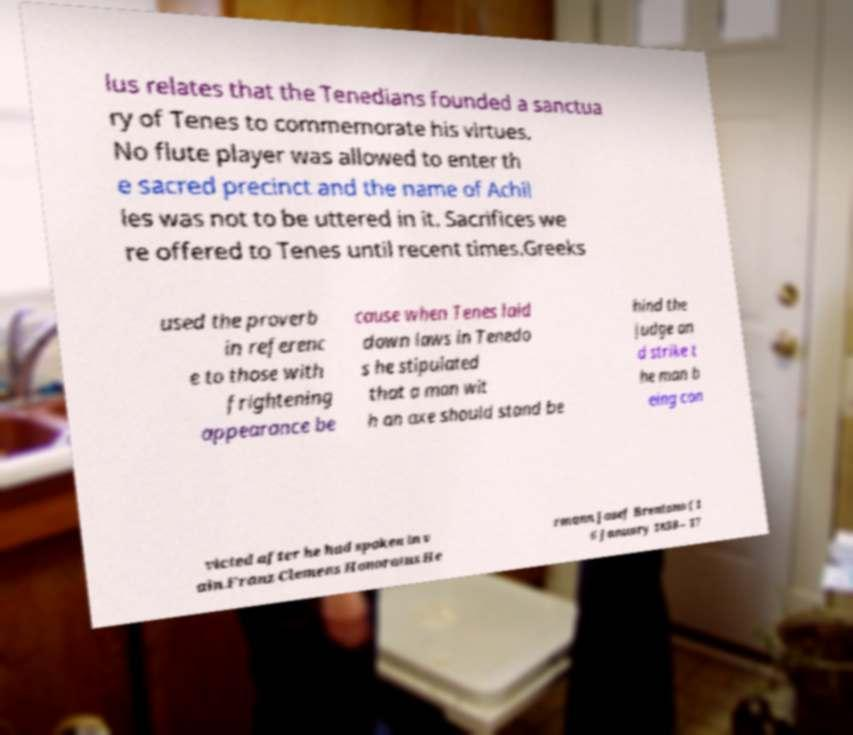I need the written content from this picture converted into text. Can you do that? lus relates that the Tenedians founded a sanctua ry of Tenes to commemorate his virtues. No flute player was allowed to enter th e sacred precinct and the name of Achil les was not to be uttered in it. Sacrifices we re offered to Tenes until recent times.Greeks used the proverb in referenc e to those with frightening appearance be cause when Tenes laid down laws in Tenedo s he stipulated that a man wit h an axe should stand be hind the judge an d strike t he man b eing con victed after he had spoken in v ain.Franz Clemens Honoratus He rmann Josef Brentano ( 1 6 January 1838 – 17 